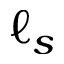Convert formula to latex. <formula><loc_0><loc_0><loc_500><loc_500>\ell _ { s }</formula> 